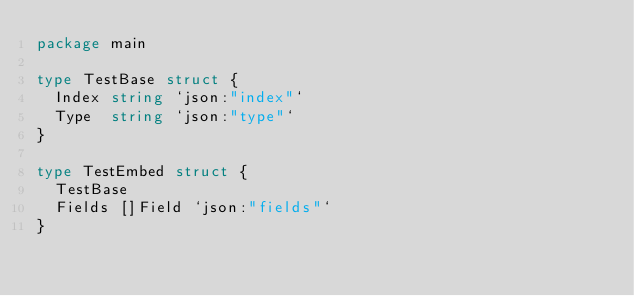Convert code to text. <code><loc_0><loc_0><loc_500><loc_500><_Go_>package main

type TestBase struct {
	Index string `json:"index"`
	Type  string `json:"type"`
}

type TestEmbed struct {
	TestBase
	Fields []Field `json:"fields"`
}
</code> 